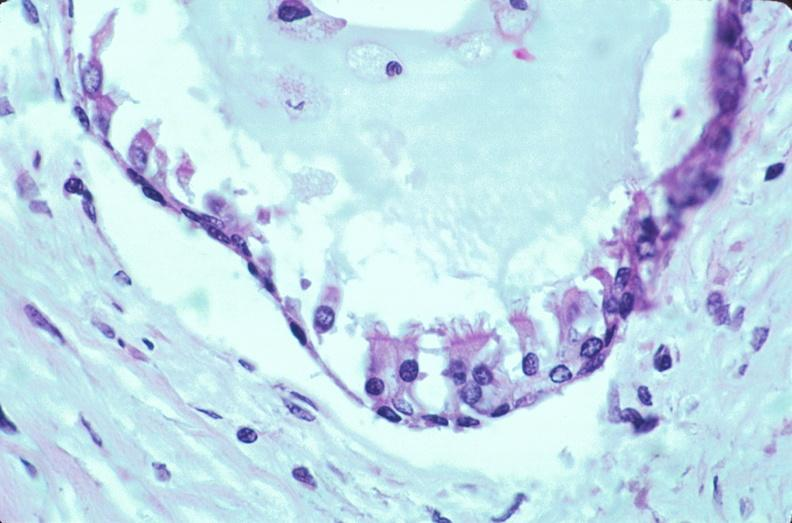what does this image show?
Answer the question using a single word or phrase. Pharyngeal pouch remnant 